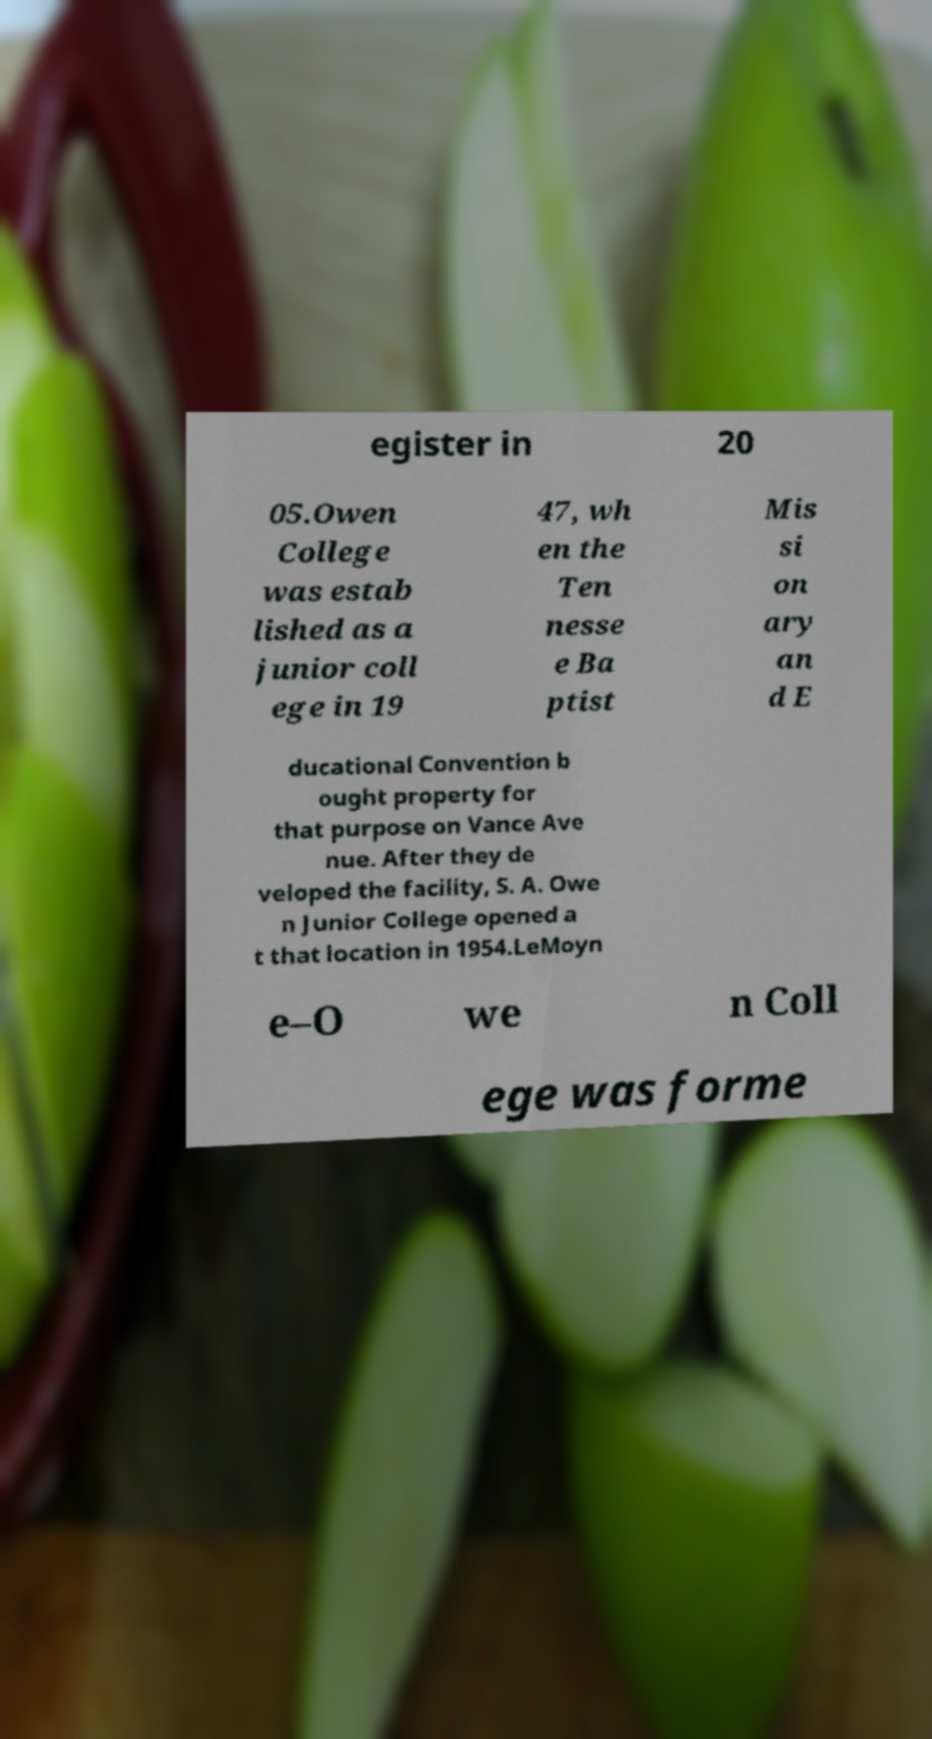For documentation purposes, I need the text within this image transcribed. Could you provide that? egister in 20 05.Owen College was estab lished as a junior coll ege in 19 47, wh en the Ten nesse e Ba ptist Mis si on ary an d E ducational Convention b ought property for that purpose on Vance Ave nue. After they de veloped the facility, S. A. Owe n Junior College opened a t that location in 1954.LeMoyn e–O we n Coll ege was forme 